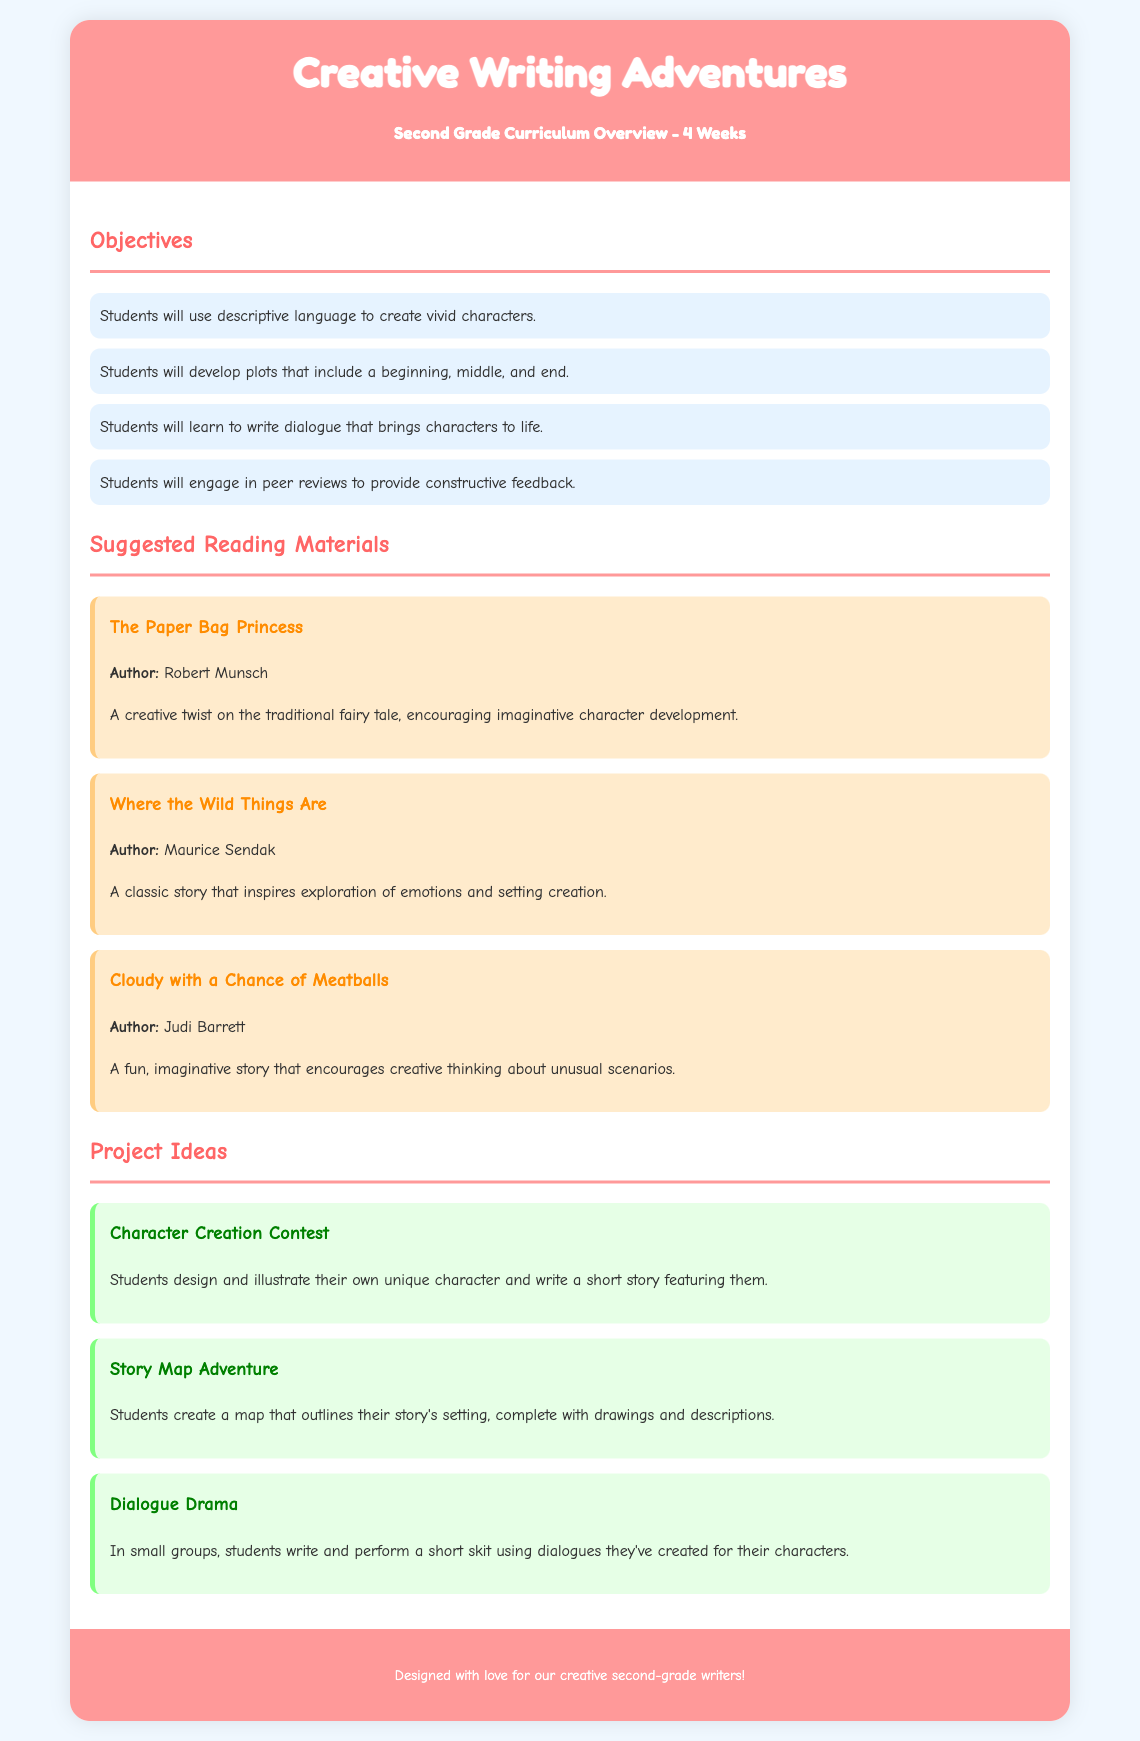What is the title of the curriculum? The title of the curriculum is prominently displayed at the top of the document.
Answer: Creative Writing Adventures How many weeks is the curriculum designed for? The duration of the curriculum is specified near the title.
Answer: 4 Weeks Who is the author of "The Paper Bag Princess"? The author is mentioned in relation to the suggested reading material section.
Answer: Robert Munsch What is the first lesson objective? The objectives list the skills students will develop during the curriculum.
Answer: Students will use descriptive language to create vivid characters What is one project idea related to dialogue? Project ideas are listed to inspire creative storytelling and include elements of dialogue.
Answer: Dialogue Drama Which book encourages exploration of emotions? The suggested reading materials include books that inspire different elements of storytelling.
Answer: Where the Wild Things Are How many lesson objectives are there in total? The number of objectives can be counted from the list provided in the document.
Answer: Four What kind of contest is included in the project ideas? The type of contest is specified among the project ideas section.
Answer: Character Creation Contest What color is the footer background? The document outlines specific colors for different sections, including the footer.
Answer: #ff9999 